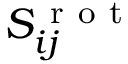<formula> <loc_0><loc_0><loc_500><loc_500>S _ { i j } ^ { r o t }</formula> 